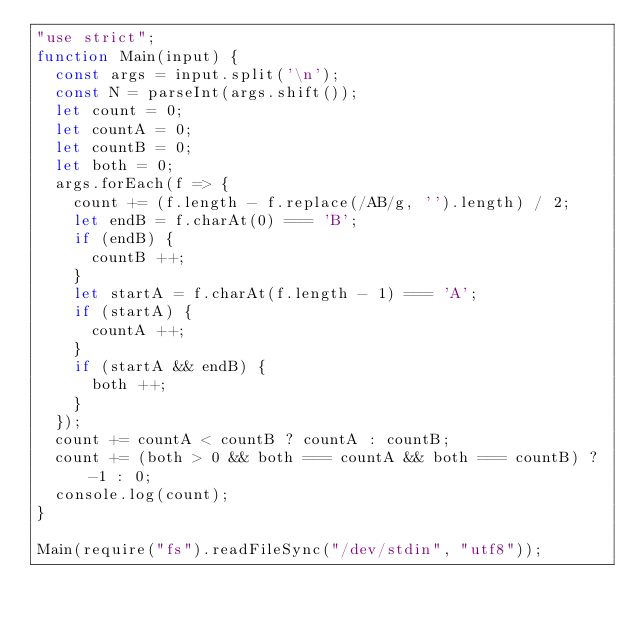<code> <loc_0><loc_0><loc_500><loc_500><_JavaScript_>"use strict";
function Main(input) {
  const args = input.split('\n');
  const N = parseInt(args.shift());
  let count = 0;
  let countA = 0;
  let countB = 0;
  let both = 0;
  args.forEach(f => {
    count += (f.length - f.replace(/AB/g, '').length) / 2;
    let endB = f.charAt(0) === 'B';
    if (endB) {
      countB ++;
    }
    let startA = f.charAt(f.length - 1) === 'A';
    if (startA) {
      countA ++;
    }
    if (startA && endB) {
      both ++;
    }
  });
  count += countA < countB ? countA : countB;
  count += (both > 0 && both === countA && both === countB) ? -1 : 0;
  console.log(count);
}

Main(require("fs").readFileSync("/dev/stdin", "utf8"));</code> 